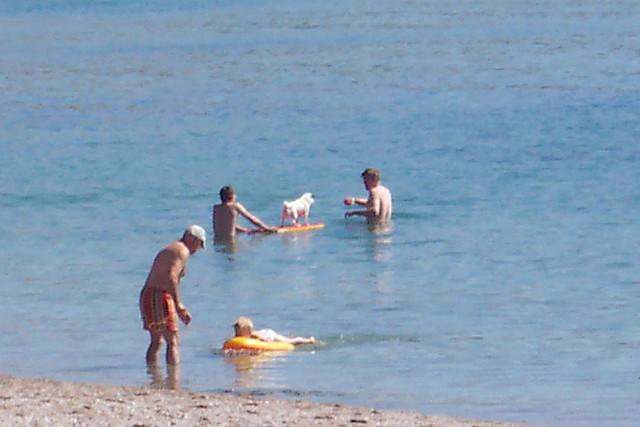What is the dog looking at?
Be succinct. Ball. What colors are the two paddle boards of the men in the black wetsuits?
Give a very brief answer. Yellow. What does the man have on top of his head?
Keep it brief. Hat. Who is wakeboarding?
Short answer required. Dog. How many people are in the water?
Be succinct. 4. How many people are in the photo?
Answer briefly. 4. Does every person have a shirt on?
Give a very brief answer. No. Is the water deep?
Short answer required. No. 